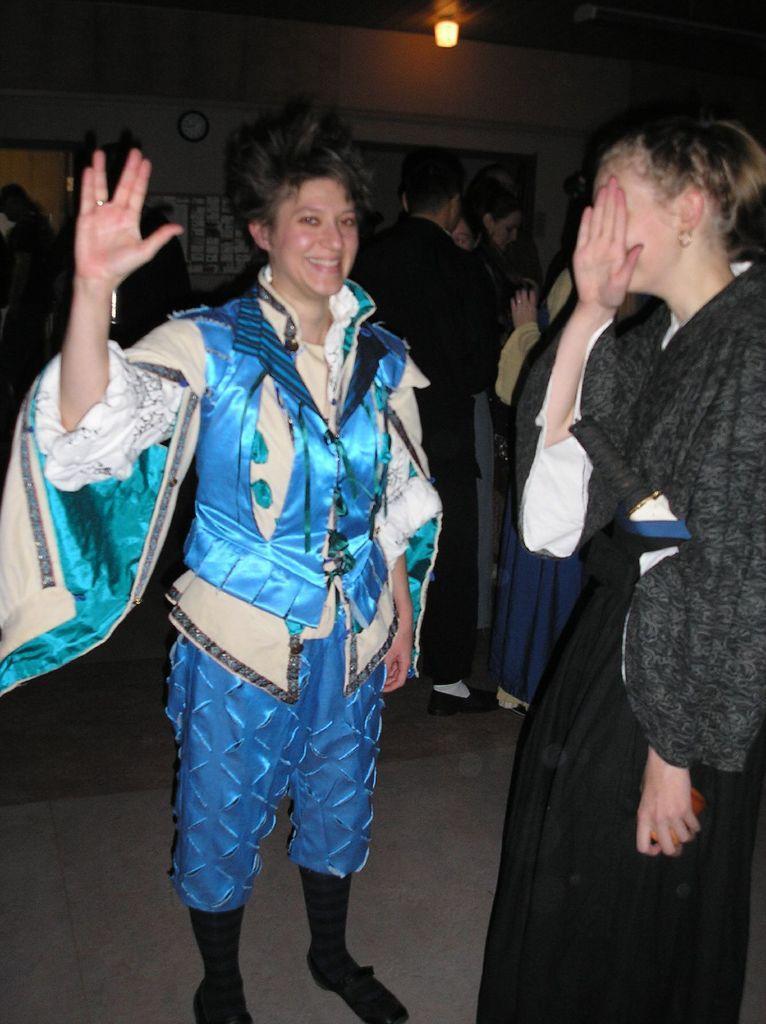Could you give a brief overview of what you see in this image? In this image we can see a group of people standing on the floor. In the background of the image we can see some papers on a board and a clock on the wall. At the top of the image we can see a light. 